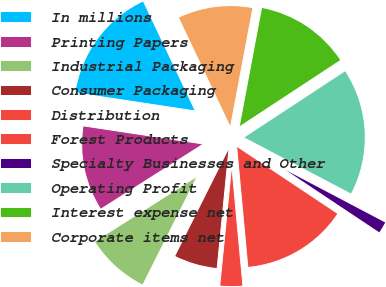Convert chart to OTSL. <chart><loc_0><loc_0><loc_500><loc_500><pie_chart><fcel>In millions<fcel>Printing Papers<fcel>Industrial Packaging<fcel>Consumer Packaging<fcel>Distribution<fcel>Forest Products<fcel>Specialty Businesses and Other<fcel>Operating Profit<fcel>Interest expense net<fcel>Corporate items net<nl><fcel>15.57%<fcel>11.39%<fcel>8.61%<fcel>5.82%<fcel>3.04%<fcel>14.18%<fcel>1.64%<fcel>16.96%<fcel>12.79%<fcel>10.0%<nl></chart> 